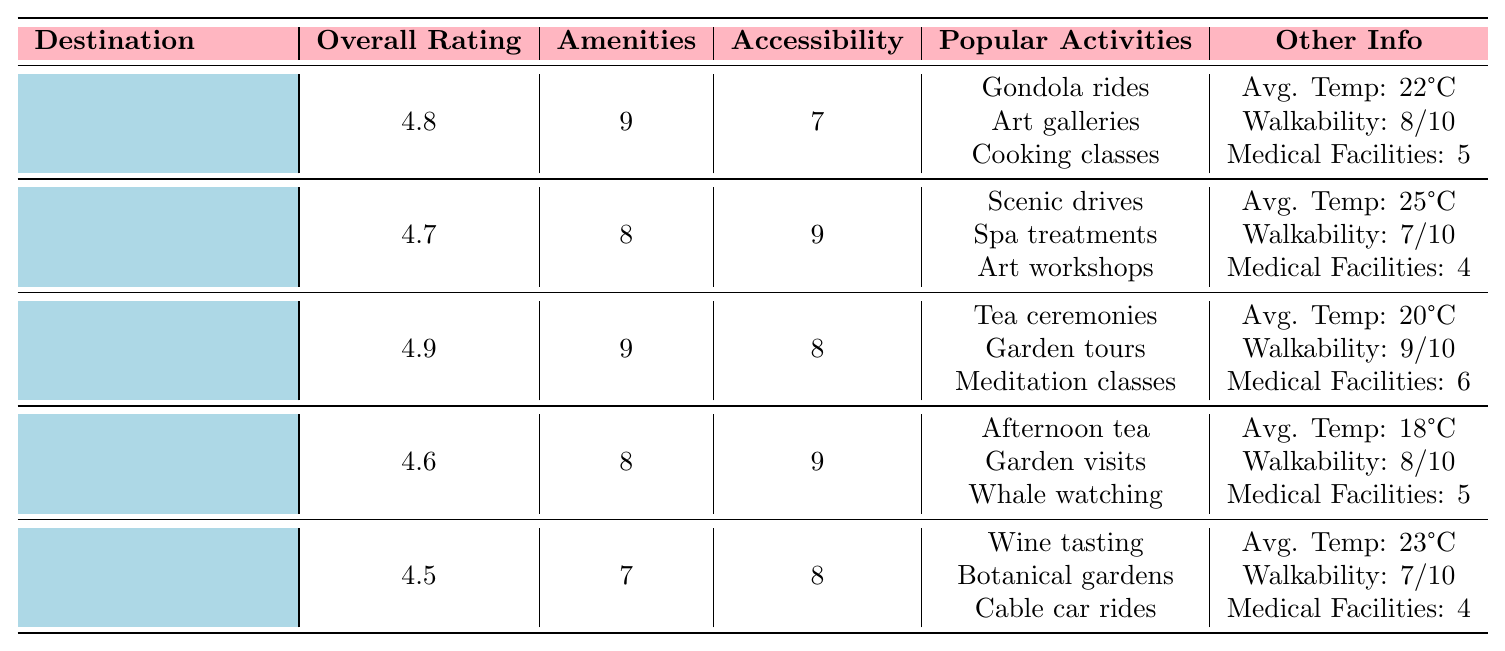What is the overall rating of Venice? According to the table, Venice has an overall rating listed as 4.8.
Answer: 4.8 Which destination has the highest accessibility score? Looking at the accessibility scores, Sedona has the highest at 9.
Answer: Sedona Are there senior discounts available in Kyoto? The table indicates that senior discounts are available in Kyoto (true).
Answer: Yes What is the average temperature in Victoria? The average temperature for Victoria is stated in the table as 18°C.
Answer: 18°C How many medical facilities are nearby in Funchal? Funchal has 4 medical facilities nearby as per the information in the table.
Answer: 4 Which city has a lower amenities score than Funchal? The amenities score for Funchal is 7, and the only city with a lower score is Funchal itself.
Answer: None What is the difference between the overall ratings of Venice and Funchal? Venice's rating is 4.8 and Funchal's is 4.5. The difference is 4.8 - 4.5 = 0.3.
Answer: 0.3 Which two destinations have an amenities score of 8? The destinations with an amenities score of 8 are Sedona and Victoria.
Answer: Sedona and Victoria What is the average walkability score of all destinations? Adding the walkability scores (8 + 7 + 9 + 8 + 7 = 39) and dividing by 5 gives 39/5 = 7.8.
Answer: 7.8 How many popular activities are listed for each destination? Each destination lists 3 popular activities according to the table.
Answer: 3 Which destination has both the highest overall rating and medical facilities nearby? Kyoto has the highest overall rating of 4.9 and also has 6 medical facilities nearby.
Answer: Kyoto 